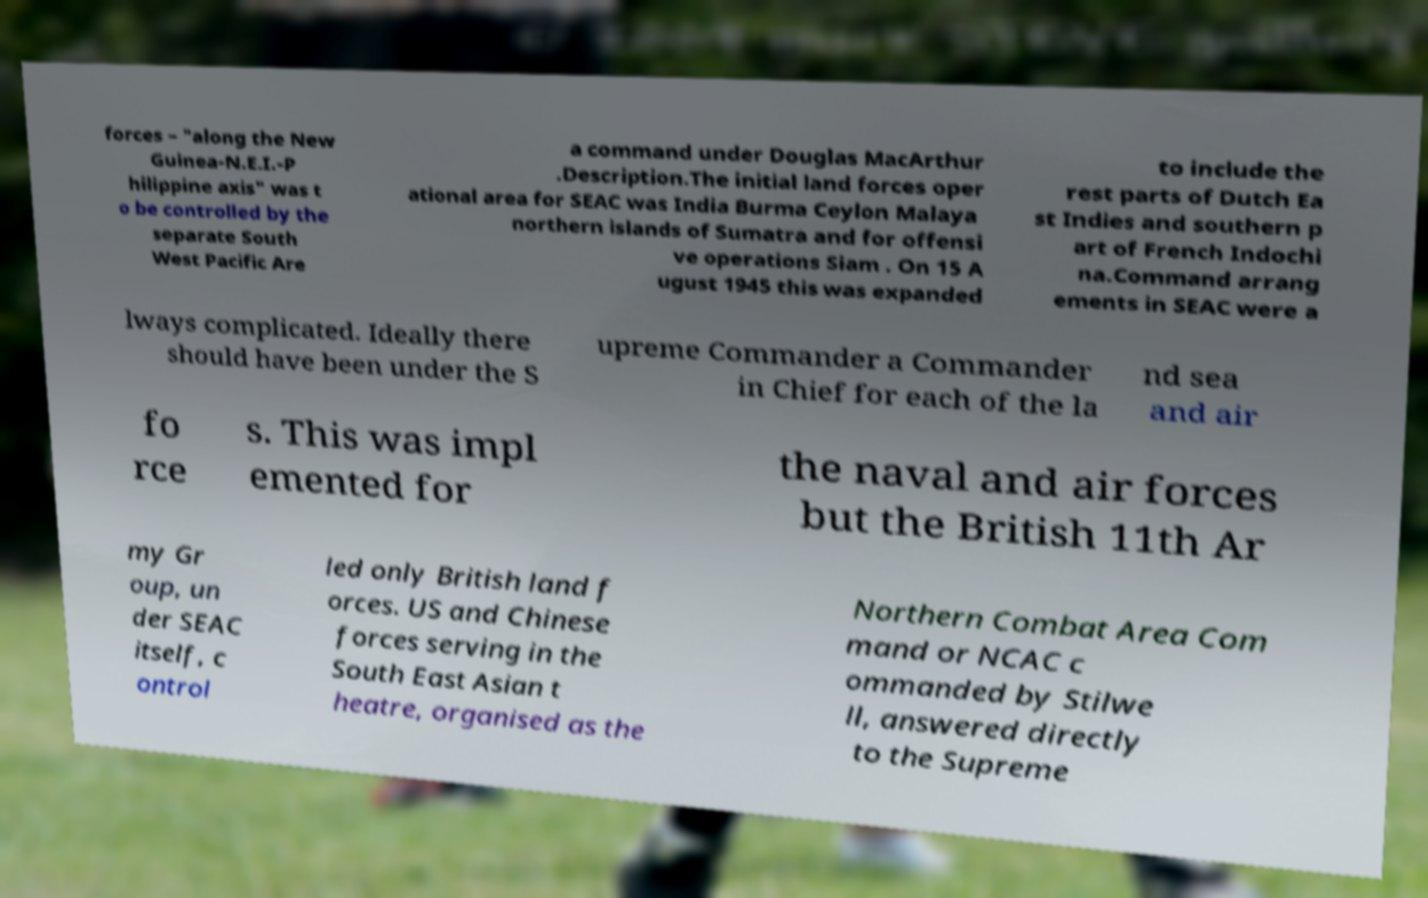Please read and relay the text visible in this image. What does it say? forces – "along the New Guinea-N.E.I.-P hilippine axis" was t o be controlled by the separate South West Pacific Are a command under Douglas MacArthur .Description.The initial land forces oper ational area for SEAC was India Burma Ceylon Malaya northern islands of Sumatra and for offensi ve operations Siam . On 15 A ugust 1945 this was expanded to include the rest parts of Dutch Ea st Indies and southern p art of French Indochi na.Command arrang ements in SEAC were a lways complicated. Ideally there should have been under the S upreme Commander a Commander in Chief for each of the la nd sea and air fo rce s. This was impl emented for the naval and air forces but the British 11th Ar my Gr oup, un der SEAC itself, c ontrol led only British land f orces. US and Chinese forces serving in the South East Asian t heatre, organised as the Northern Combat Area Com mand or NCAC c ommanded by Stilwe ll, answered directly to the Supreme 